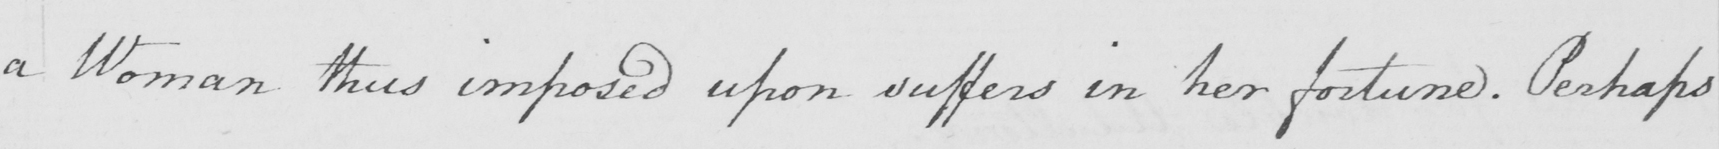Can you tell me what this handwritten text says? a Woman thus imposed upon suffers in her fortune . Perhaps 